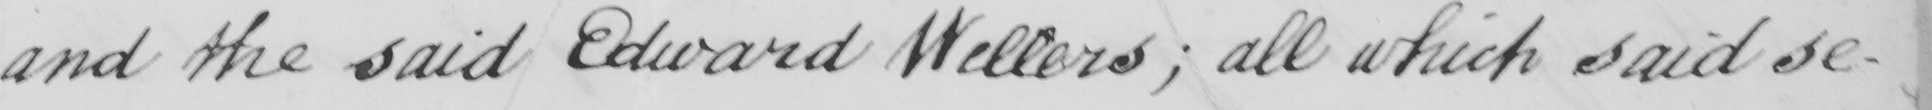Can you read and transcribe this handwriting? and the said Edward Wellers ; all which said se- 